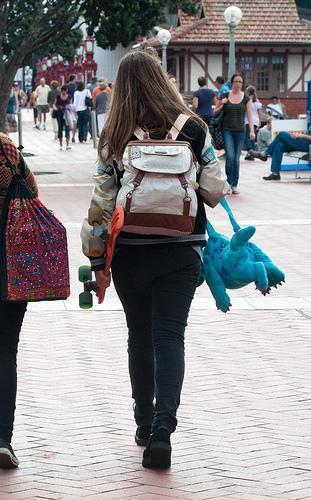How many skateboards the woman carrying?
Give a very brief answer. 1. 